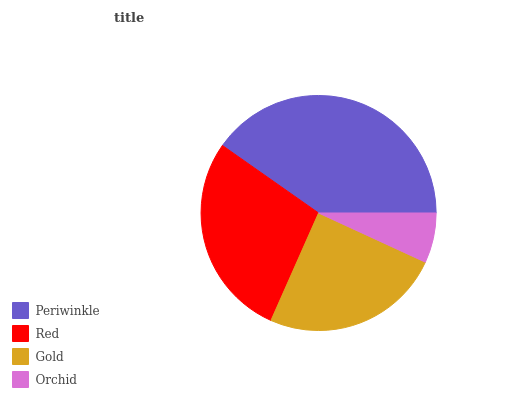Is Orchid the minimum?
Answer yes or no. Yes. Is Periwinkle the maximum?
Answer yes or no. Yes. Is Red the minimum?
Answer yes or no. No. Is Red the maximum?
Answer yes or no. No. Is Periwinkle greater than Red?
Answer yes or no. Yes. Is Red less than Periwinkle?
Answer yes or no. Yes. Is Red greater than Periwinkle?
Answer yes or no. No. Is Periwinkle less than Red?
Answer yes or no. No. Is Red the high median?
Answer yes or no. Yes. Is Gold the low median?
Answer yes or no. Yes. Is Orchid the high median?
Answer yes or no. No. Is Red the low median?
Answer yes or no. No. 